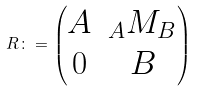<formula> <loc_0><loc_0><loc_500><loc_500>R \colon = \begin{pmatrix} A & { _ { A } M _ { B } } \\ 0 & B \end{pmatrix}</formula> 